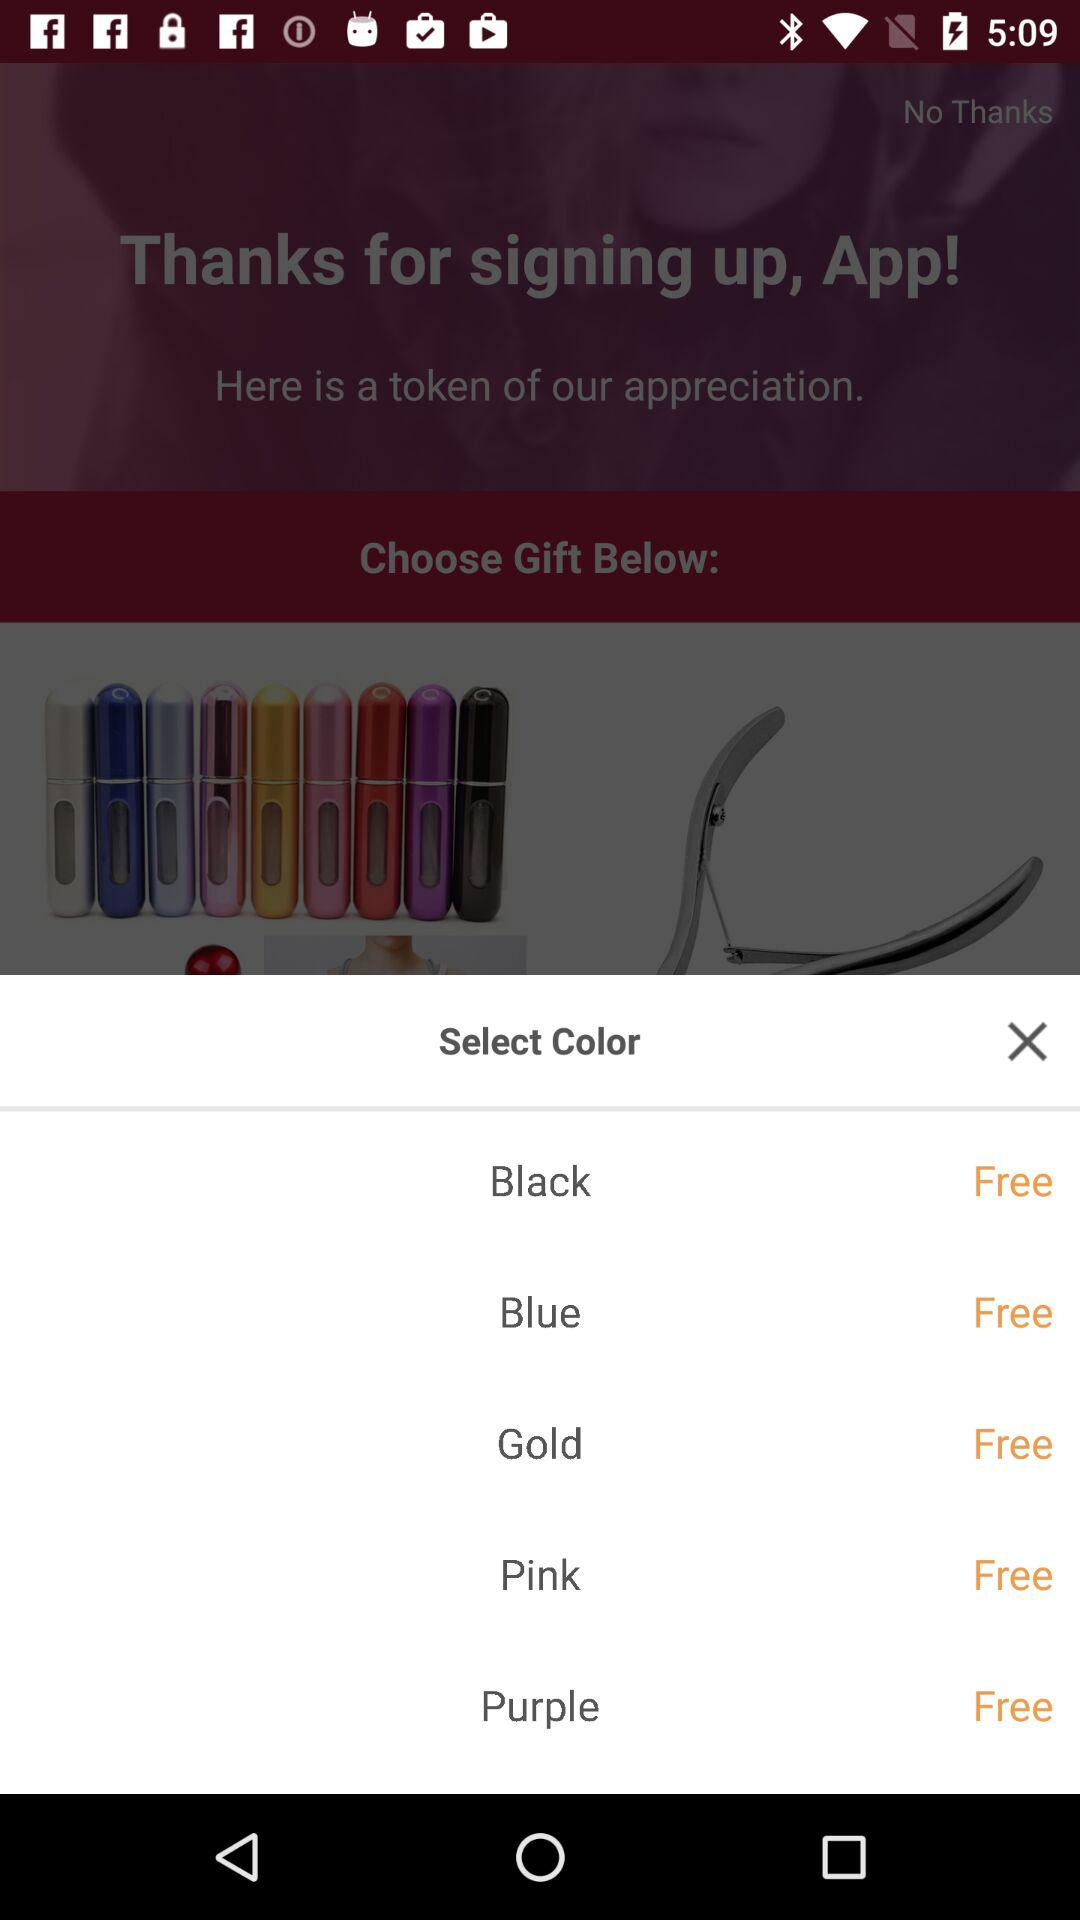What are the available colors? The available colors are black, blue, gold, pink and purple. 